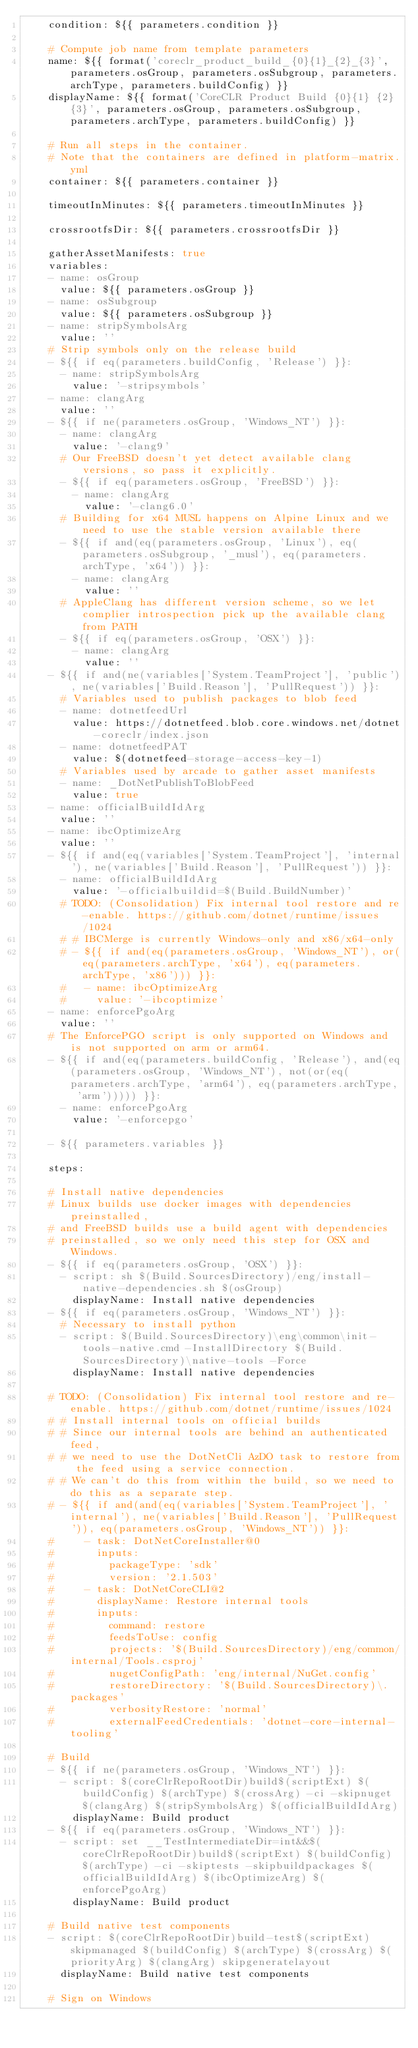<code> <loc_0><loc_0><loc_500><loc_500><_YAML_>    condition: ${{ parameters.condition }}

    # Compute job name from template parameters
    name: ${{ format('coreclr_product_build_{0}{1}_{2}_{3}', parameters.osGroup, parameters.osSubgroup, parameters.archType, parameters.buildConfig) }}
    displayName: ${{ format('CoreCLR Product Build {0}{1} {2} {3}', parameters.osGroup, parameters.osSubgroup, parameters.archType, parameters.buildConfig) }}

    # Run all steps in the container.
    # Note that the containers are defined in platform-matrix.yml
    container: ${{ parameters.container }}

    timeoutInMinutes: ${{ parameters.timeoutInMinutes }}

    crossrootfsDir: ${{ parameters.crossrootfsDir }}

    gatherAssetManifests: true
    variables:
    - name: osGroup
      value: ${{ parameters.osGroup }}
    - name: osSubgroup
      value: ${{ parameters.osSubgroup }}
    - name: stripSymbolsArg
      value: ''
    # Strip symbols only on the release build
    - ${{ if eq(parameters.buildConfig, 'Release') }}:
      - name: stripSymbolsArg
        value: '-stripsymbols'
    - name: clangArg
      value: ''
    - ${{ if ne(parameters.osGroup, 'Windows_NT') }}:
      - name: clangArg
        value: '-clang9'
      # Our FreeBSD doesn't yet detect available clang versions, so pass it explicitly.
      - ${{ if eq(parameters.osGroup, 'FreeBSD') }}:
        - name: clangArg
          value: '-clang6.0'
      # Building for x64 MUSL happens on Alpine Linux and we need to use the stable version available there
      - ${{ if and(eq(parameters.osGroup, 'Linux'), eq(parameters.osSubgroup, '_musl'), eq(parameters.archType, 'x64')) }}:
        - name: clangArg
          value: ''
      # AppleClang has different version scheme, so we let complier introspection pick up the available clang from PATH
      - ${{ if eq(parameters.osGroup, 'OSX') }}:
        - name: clangArg
          value: ''
    - ${{ if and(ne(variables['System.TeamProject'], 'public'), ne(variables['Build.Reason'], 'PullRequest')) }}:
      # Variables used to publish packages to blob feed
      - name: dotnetfeedUrl
        value: https://dotnetfeed.blob.core.windows.net/dotnet-coreclr/index.json
      - name: dotnetfeedPAT
        value: $(dotnetfeed-storage-access-key-1)
      # Variables used by arcade to gather asset manifests
      - name: _DotNetPublishToBlobFeed
        value: true
    - name: officialBuildIdArg
      value: ''
    - name: ibcOptimizeArg
      value: ''
    - ${{ if and(eq(variables['System.TeamProject'], 'internal'), ne(variables['Build.Reason'], 'PullRequest')) }}:
      - name: officialBuildIdArg
        value: '-officialbuildid=$(Build.BuildNumber)'
      # TODO: (Consolidation) Fix internal tool restore and re-enable. https://github.com/dotnet/runtime/issues/1024
      # # IBCMerge is currently Windows-only and x86/x64-only
      # - ${{ if and(eq(parameters.osGroup, 'Windows_NT'), or(eq(parameters.archType, 'x64'), eq(parameters.archType, 'x86'))) }}:
      #   - name: ibcOptimizeArg
      #     value: '-ibcoptimize'
    - name: enforcePgoArg
      value: ''
    # The EnforcePGO script is only supported on Windows and is not supported on arm or arm64.
    - ${{ if and(eq(parameters.buildConfig, 'Release'), and(eq(parameters.osGroup, 'Windows_NT'), not(or(eq(parameters.archType, 'arm64'), eq(parameters.archType, 'arm'))))) }}:
      - name: enforcePgoArg
        value: '-enforcepgo'

    - ${{ parameters.variables }}

    steps:

    # Install native dependencies
    # Linux builds use docker images with dependencies preinstalled,
    # and FreeBSD builds use a build agent with dependencies
    # preinstalled, so we only need this step for OSX and Windows.
    - ${{ if eq(parameters.osGroup, 'OSX') }}:
      - script: sh $(Build.SourcesDirectory)/eng/install-native-dependencies.sh $(osGroup)
        displayName: Install native dependencies
    - ${{ if eq(parameters.osGroup, 'Windows_NT') }}:
      # Necessary to install python
      - script: $(Build.SourcesDirectory)\eng\common\init-tools-native.cmd -InstallDirectory $(Build.SourcesDirectory)\native-tools -Force
        displayName: Install native dependencies

    # TODO: (Consolidation) Fix internal tool restore and re-enable. https://github.com/dotnet/runtime/issues/1024
    # # Install internal tools on official builds
    # # Since our internal tools are behind an authenticated feed,
    # # we need to use the DotNetCli AzDO task to restore from the feed using a service connection.
    # # We can't do this from within the build, so we need to do this as a separate step.
    # - ${{ if and(and(eq(variables['System.TeamProject'], 'internal'), ne(variables['Build.Reason'], 'PullRequest')), eq(parameters.osGroup, 'Windows_NT')) }}:
    #     - task: DotNetCoreInstaller@0
    #       inputs:
    #         packageType: 'sdk'
    #         version: '2.1.503'
    #     - task: DotNetCoreCLI@2
    #       displayName: Restore internal tools
    #       inputs:
    #         command: restore
    #         feedsToUse: config
    #         projects: '$(Build.SourcesDirectory)/eng/common/internal/Tools.csproj'
    #         nugetConfigPath: 'eng/internal/NuGet.config'
    #         restoreDirectory: '$(Build.SourcesDirectory)\.packages'
    #         verbosityRestore: 'normal'
    #         externalFeedCredentials: 'dotnet-core-internal-tooling'

    # Build
    - ${{ if ne(parameters.osGroup, 'Windows_NT') }}:
      - script: $(coreClrRepoRootDir)build$(scriptExt) $(buildConfig) $(archType) $(crossArg) -ci -skipnuget $(clangArg) $(stripSymbolsArg) $(officialBuildIdArg)
        displayName: Build product
    - ${{ if eq(parameters.osGroup, 'Windows_NT') }}:
      - script: set __TestIntermediateDir=int&&$(coreClrRepoRootDir)build$(scriptExt) $(buildConfig) $(archType) -ci -skiptests -skipbuildpackages $(officialBuildIdArg) $(ibcOptimizeArg) $(enforcePgoArg)
        displayName: Build product

    # Build native test components
    - script: $(coreClrRepoRootDir)build-test$(scriptExt) skipmanaged $(buildConfig) $(archType) $(crossArg) $(priorityArg) $(clangArg) skipgeneratelayout
      displayName: Build native test components

    # Sign on Windows</code> 